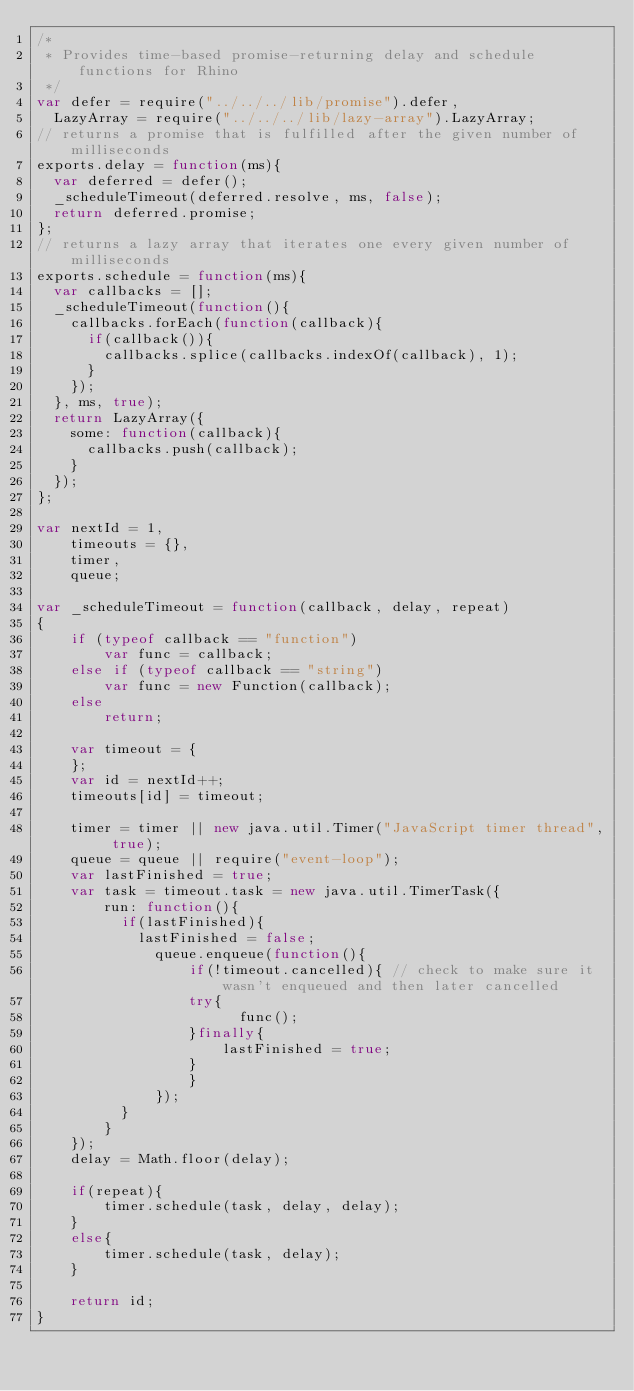<code> <loc_0><loc_0><loc_500><loc_500><_JavaScript_>/*
 * Provides time-based promise-returning delay and schedule functions for Rhino
 */
var defer = require("../../../lib/promise").defer,
	LazyArray = require("../../../lib/lazy-array").LazyArray;
// returns a promise that is fulfilled after the given number of milliseconds
exports.delay = function(ms){
	var deferred = defer();
	_scheduleTimeout(deferred.resolve, ms, false);
	return deferred.promise;
};
// returns a lazy array that iterates one every given number of milliseconds
exports.schedule = function(ms){
	var callbacks = [];
	_scheduleTimeout(function(){
		callbacks.forEach(function(callback){
			if(callback()){
				callbacks.splice(callbacks.indexOf(callback), 1);
			}
		});
	}, ms, true);
	return LazyArray({
		some: function(callback){
			callbacks.push(callback);
		}
	});
};

var nextId = 1,
    timeouts = {},
    timer, 
    queue;

var _scheduleTimeout = function(callback, delay, repeat)
{
    if (typeof callback == "function")
        var func = callback;
    else if (typeof callback == "string")
        var func = new Function(callback);
    else
        return;

    var timeout = {
    };
    var id = nextId++;
    timeouts[id] = timeout;

    timer = timer || new java.util.Timer("JavaScript timer thread", true);
    queue = queue || require("event-loop");
    var lastFinished = true;
    var task = timeout.task = new java.util.TimerTask({
        run: function(){
        	if(lastFinished){
	        	lastFinished = false;
	            queue.enqueue(function(){
	                if(!timeout.cancelled){ // check to make sure it wasn't enqueued and then later cancelled
		            	try{
		                    func();
		            	}finally{
		                	lastFinished = true;
		            	}
	                }
	            });
        	}
        }
    });
    delay = Math.floor(delay);
    
    if(repeat){
        timer.schedule(task, delay, delay);
    }
    else{
        timer.schedule(task, delay);
    }
    
    return id;
}


</code> 